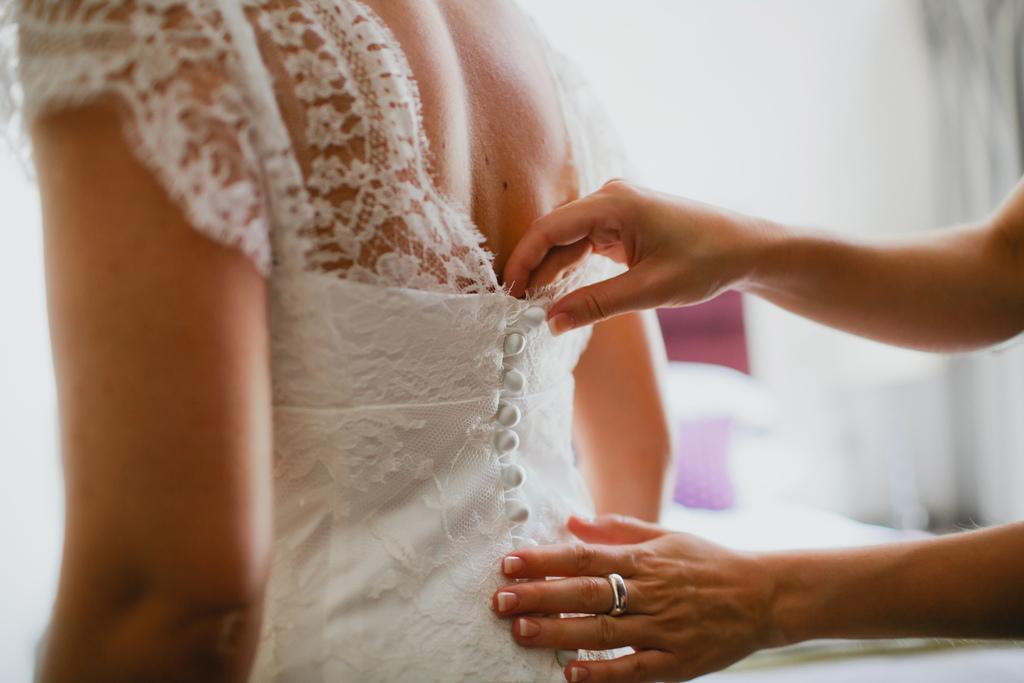Could you give a brief overview of what you see in this image? There is a lady wearing white gown. And another person wearing a silver ring is touching the lady. In the background it is blurred. 